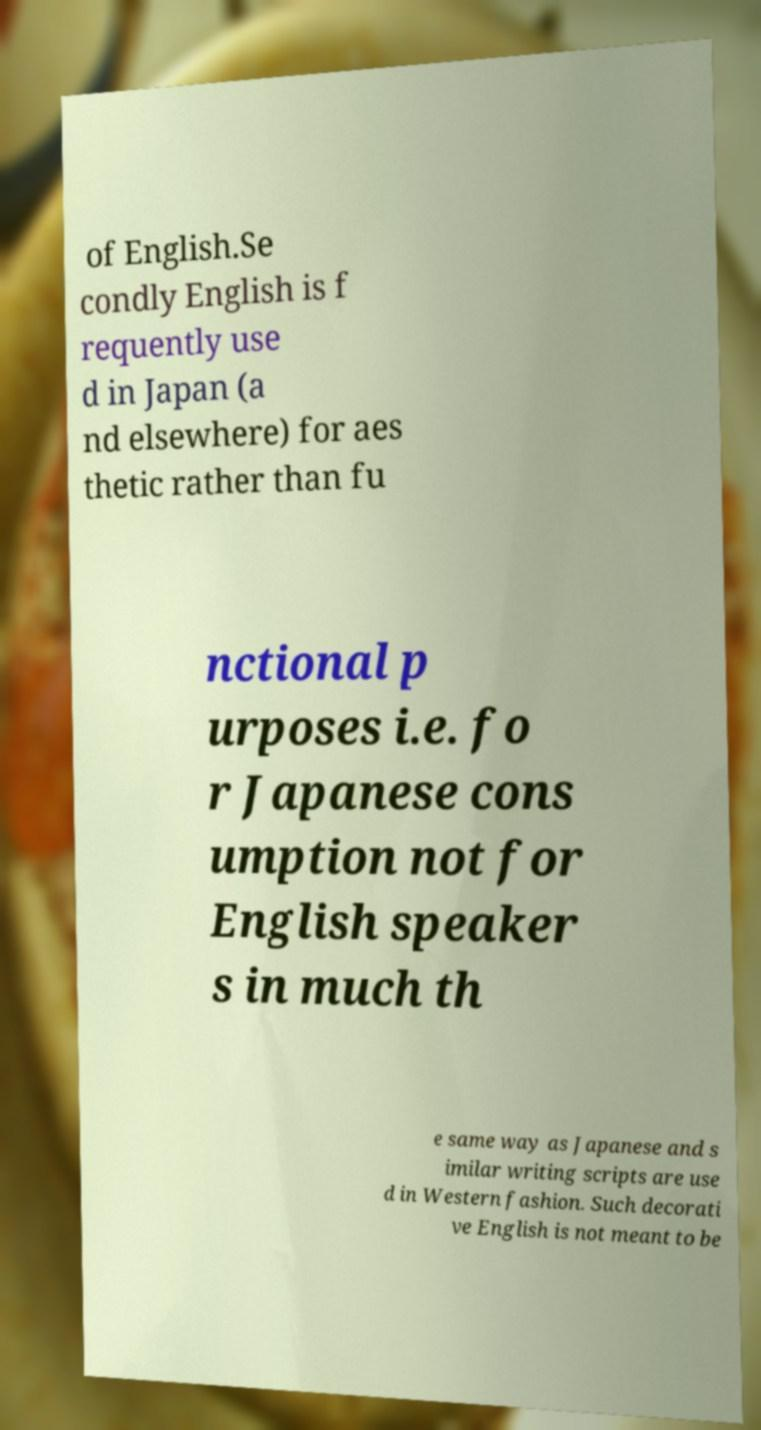Please identify and transcribe the text found in this image. of English.Se condly English is f requently use d in Japan (a nd elsewhere) for aes thetic rather than fu nctional p urposes i.e. fo r Japanese cons umption not for English speaker s in much th e same way as Japanese and s imilar writing scripts are use d in Western fashion. Such decorati ve English is not meant to be 